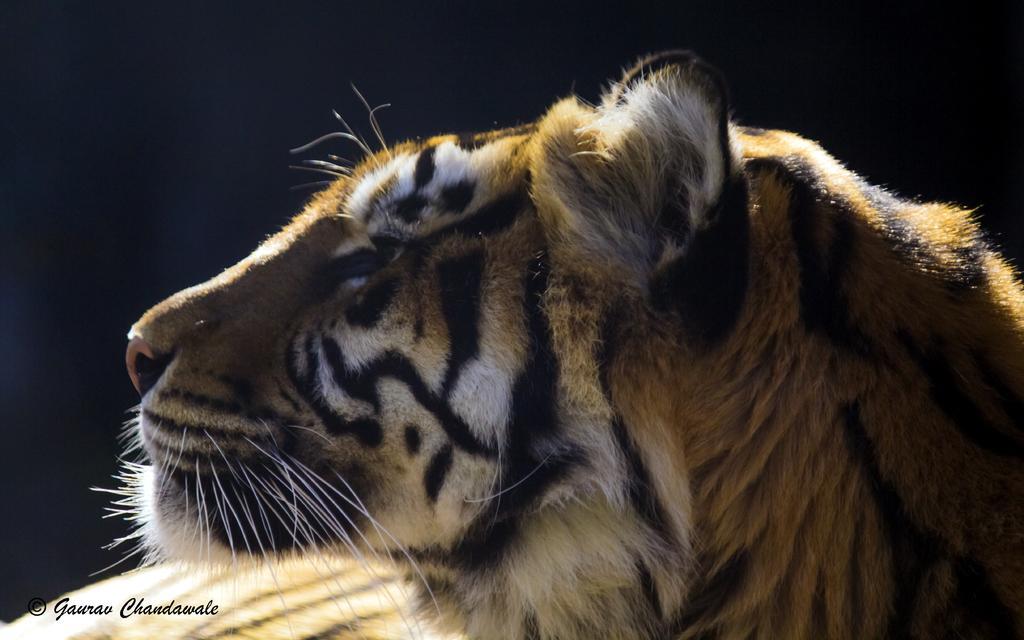Describe this image in one or two sentences. There is a tiger and the background is black in color. 